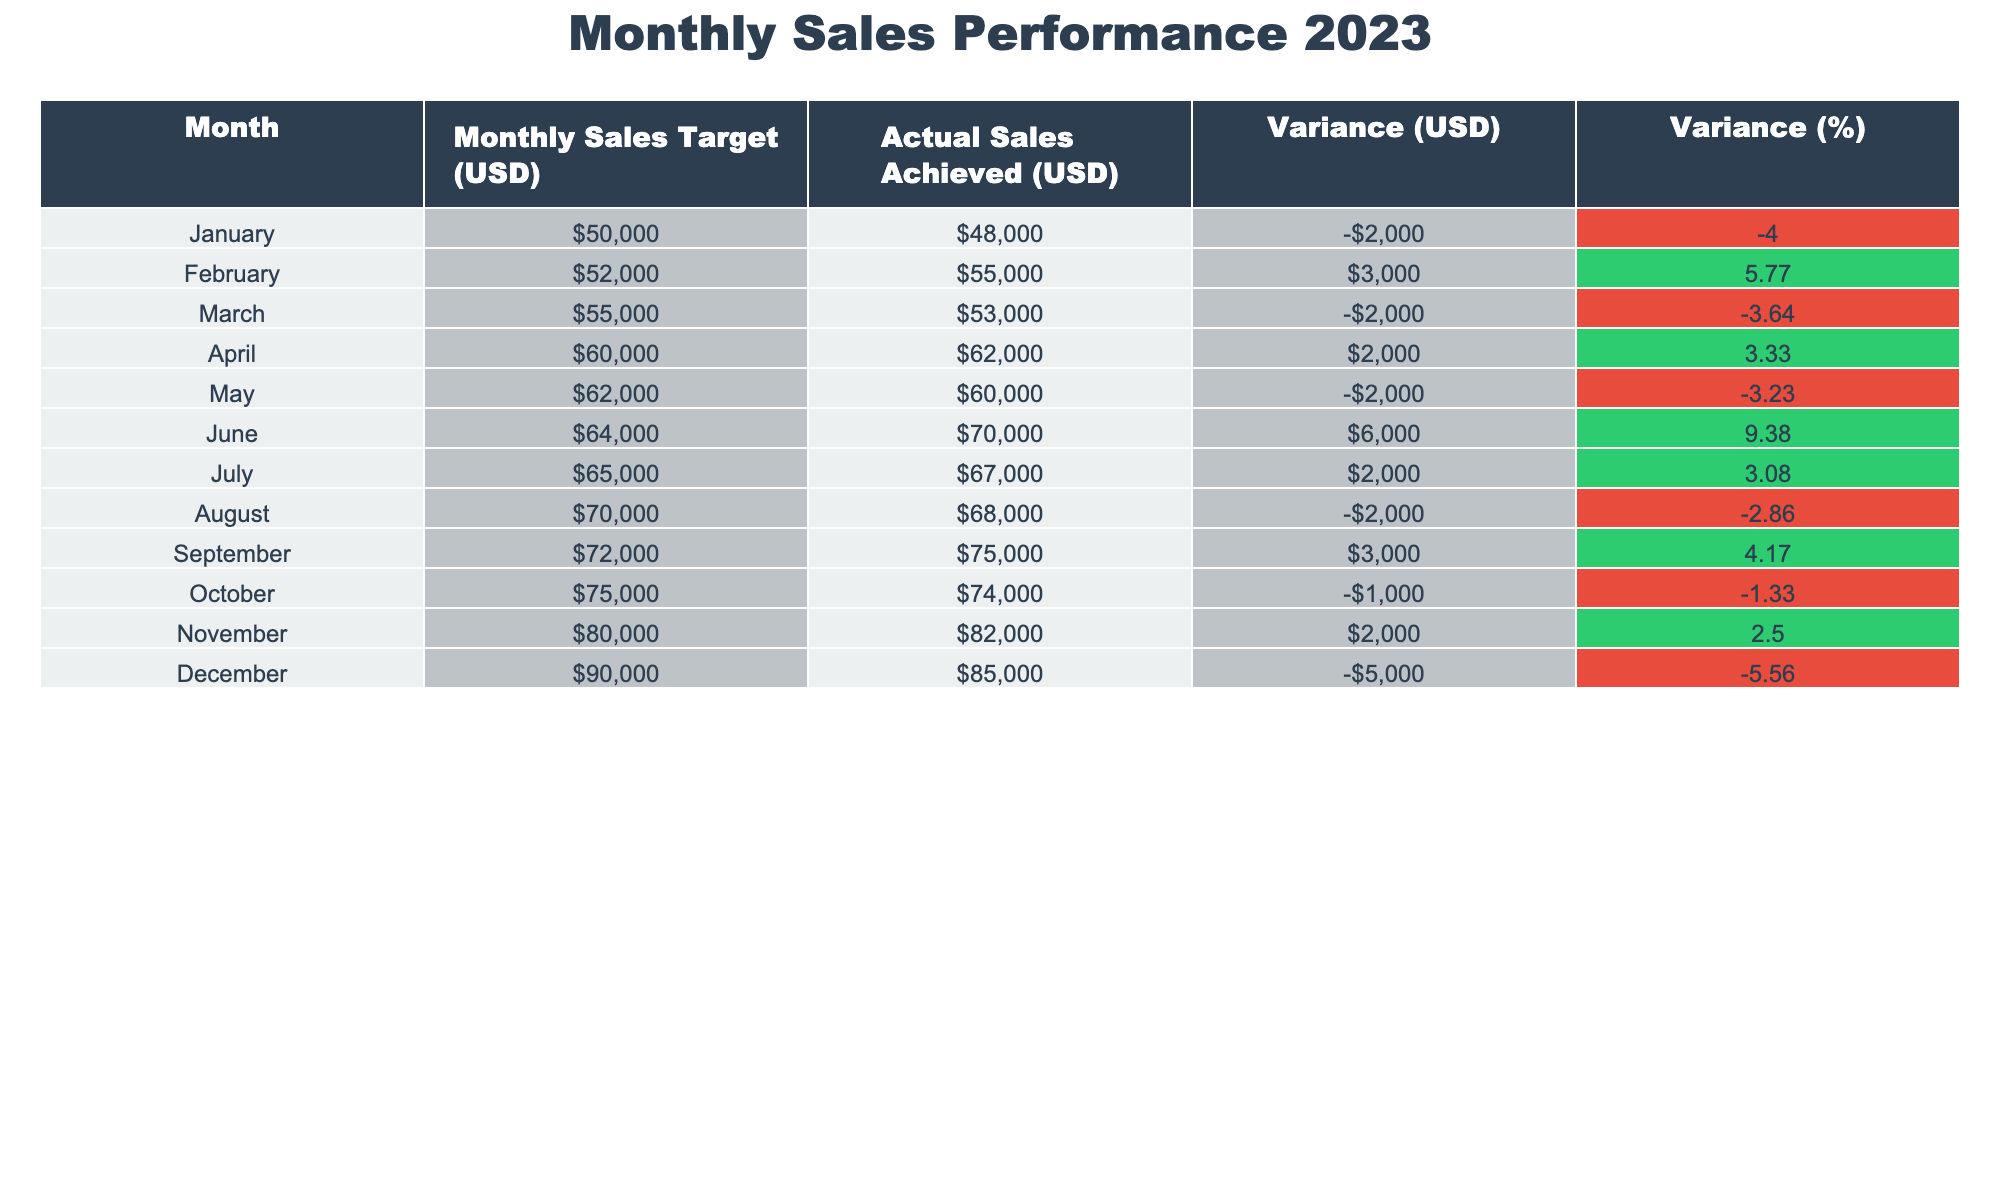What was the actual sales achieved in July? The table lists the actual sales achieved for each month. For July, the value is given as USD 67,000.
Answer: 67,000 Which month had the highest sales target? By checking the values in the "Monthly Sales Target" column, December has the highest target of USD 90,000.
Answer: 90,000 What is the variance for March? The variance for March can be found in the "Variance (USD)" column. For March, it is -2,000 USD.
Answer: -2,000 Was the actual sales achieved lower than the target in June? Looking at the values for June in the table, the actual sales is USD 70,000, which exceeds the target of USD 64,000, indicating that it was higher.
Answer: No What is the total variance for the first half of the year (January to June)? The variances for January to June are: -2,000, 3,000, -2,000, 2,000, -2,000, and 6,000. Summing these gives -2,000 + 3,000 - 2,000 + 2,000 - 2,000 + 6,000 = 5,000 USD.
Answer: 5,000 How many months were there with actual sales below the target? By analyzing the "Variance (USD)" column, we see that for January, March, May, August, October, and December, the variances are negative, indicating actual sales were below the targets in these months. That totals 6 months.
Answer: 6 What is the average variance percentage for all months? To calculate the average, we add all the values in the "Variance (%)" column, which are: -4, 5.77, -3.64, 3.33, -3.23, 9.38, 3.08, -2.86, 4.17, -1.33, 2.5, -5.56. The total is 5.2, and dividing by 12 months gives an average of 5.2 / 12 = approximately 0.43%.
Answer: Approximately 0.43% In which month was the highest percentage of variance achieved? The column "Variance (%)" shows that June had the highest positive variance of 9.38%.
Answer: June Was there any month where actual sales exceeded the target by more than 5,000 USD? By examining the table, no month shows a variance exceeding 5,000 USD in a positive manner. The largest positive variance is 6,000 USD in June, which is below that threshold.
Answer: No What was the trend of actual sales achieved from January to June? Reviewing the actual sales figures from January (48,000) to June (70,000), we see a positive trend, as sales increased each month except for March and May, which both had drops.
Answer: Positive trend with some fluctuations 